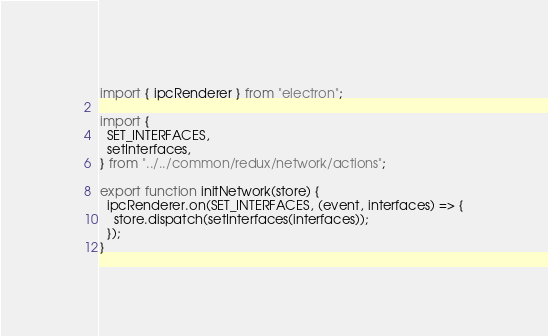<code> <loc_0><loc_0><loc_500><loc_500><_JavaScript_>import { ipcRenderer } from "electron";

import {
  SET_INTERFACES,
  setInterfaces,
} from "../../common/redux/network/actions";

export function initNetwork(store) {
  ipcRenderer.on(SET_INTERFACES, (event, interfaces) => {
    store.dispatch(setInterfaces(interfaces));
  });
}
</code> 